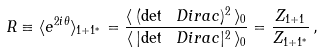<formula> <loc_0><loc_0><loc_500><loc_500>R \equiv \langle e ^ { 2 i \theta } \rangle _ { 1 + 1 ^ { * } } = \frac { \langle \, { ( \det \ D i r a c ) ^ { 2 } } \, \rangle _ { 0 } } { \langle \, { | { \det \ D i r a c } | ^ { 2 } } \, \rangle _ { 0 } } = \frac { Z _ { 1 + 1 } } { Z _ { 1 + 1 ^ { * } } } \, ,</formula> 